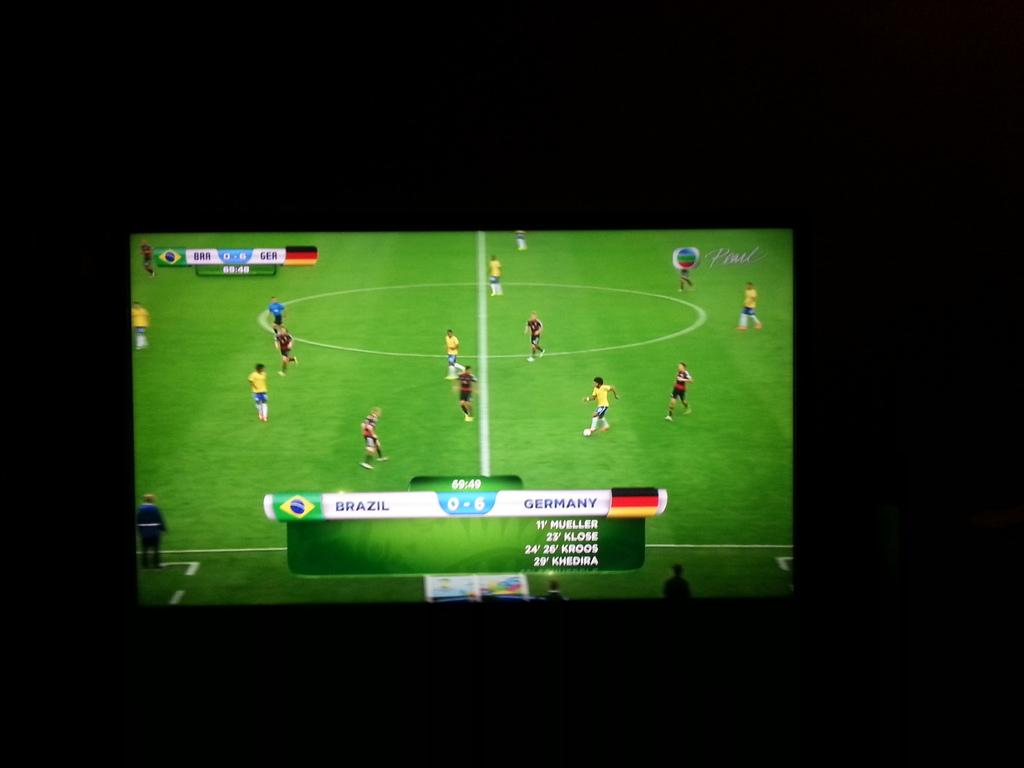<image>
Summarize the visual content of the image. A soccer game between Germany and Brazil is playing on the television screen. 